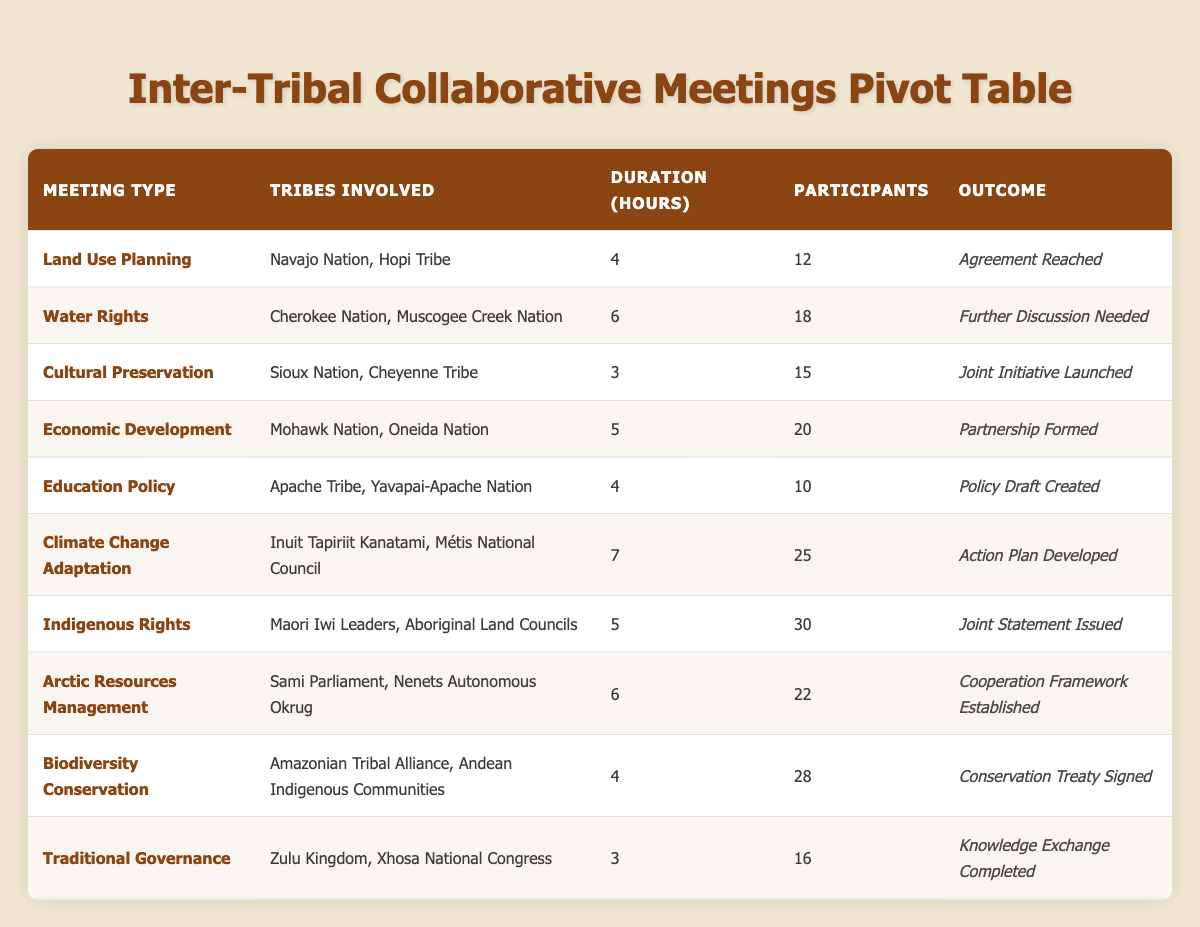What is the outcome of the meeting between the Navajo Nation and the Hopi Tribe? The outcome for this meeting, listed under "Land Use Planning," is "Agreement Reached." This can be found in the row corresponding to the "Land Use Planning" meeting type.
Answer: Agreement Reached How many participants were involved in the meeting focused on "Indigenous Rights"? The meeting titled "Indigenous Rights" involved 30 participants. This information is presented in the corresponding row for that meeting type.
Answer: 30 What is the total duration of meetings regarding "Climate Change Adaptation"? There is one meeting related to "Climate Change Adaptation," which lasted for 7 hours. Since there’s only one meeting, the total duration is 7 hours.
Answer: 7 Did the "Mohawk Nation" and "Oneida Nation" meet for "Cultural Preservation"? No, they did not. The "Mohawk Nation" and "Oneida Nation" met for "Economic Development," not "Cultural Preservation." This information is reflected in their respective meeting type listed in the table.
Answer: No What meeting type had the highest number of participants? The meeting type "Indigenous Rights" had the highest number of participants, totaling 30. By comparing the participants across all meeting types, this stands out as the maximum value.
Answer: Indigenous Rights How many different meeting types were conducted? There are 10 unique meeting types listed in the table. Each row represents a different type, so by counting the rows in the "Meeting Type" column, we confirm there are 10 distinct types.
Answer: 10 What is the average duration of meetings related to "Traditional Governance" and "Cultural Preservation"? There’s one meeting for "Traditional Governance" lasting 3 hours and one for "Cultural Preservation" lasting 3 hours. To find the average, we sum the durations (3 + 3) = 6 and then divide by 2 (the number of meetings), which gives us an average of 3 hours.
Answer: 3 How many meetings resulted in an "Action Plan Developed"? There is one meeting that resulted in "Action Plan Developed," specifically the one involving the Inuit Tapiriit Kanatami and Métis National Council under "Climate Change Adaptation." Therefore, the count is one meeting.
Answer: 1 Is it true that all meetings had more than 10 participants? No, it is not true. The meeting on "Education Policy" had only 10 participants, which is not over 10. This can be verified by checking the "Participants" column for all meetings.
Answer: No 